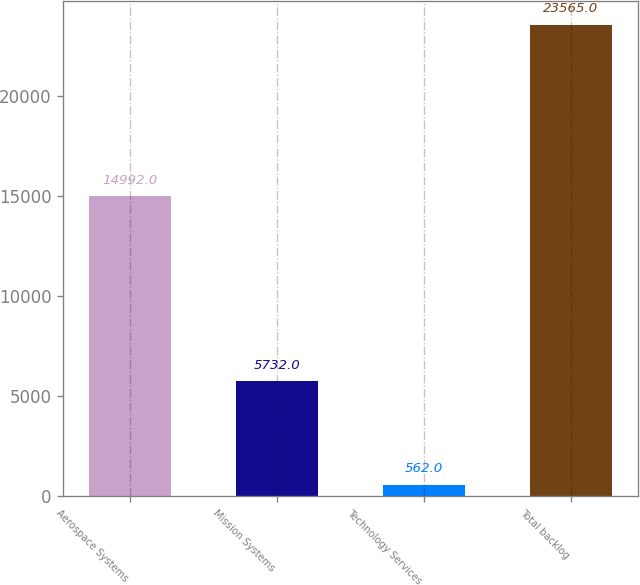Convert chart. <chart><loc_0><loc_0><loc_500><loc_500><bar_chart><fcel>Aerospace Systems<fcel>Mission Systems<fcel>Technology Services<fcel>Total backlog<nl><fcel>14992<fcel>5732<fcel>562<fcel>23565<nl></chart> 